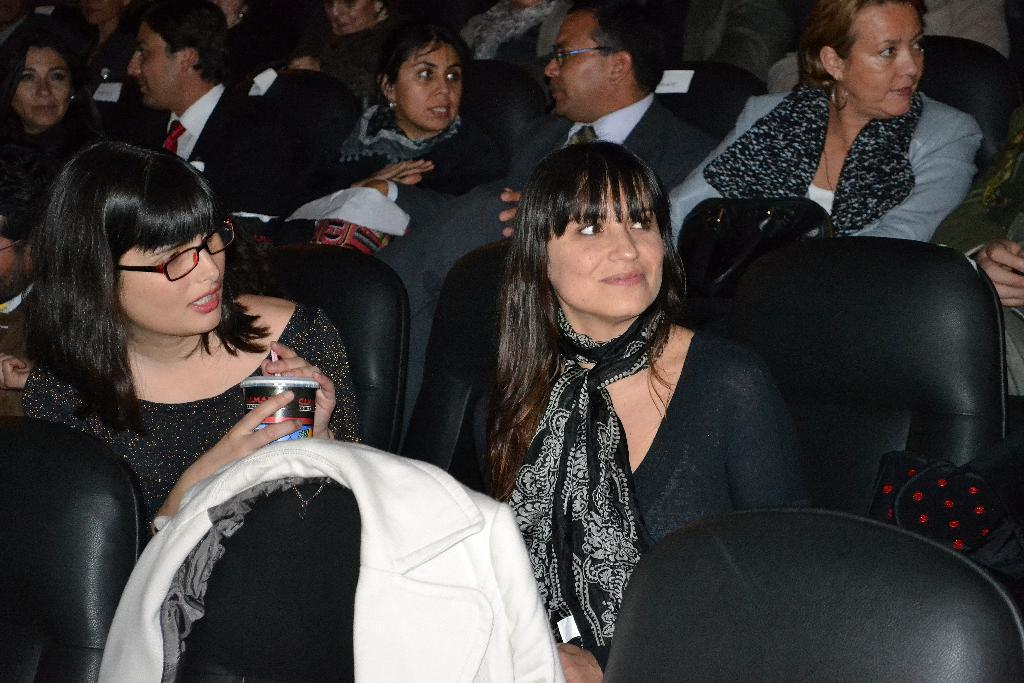Who or what can be seen in the image? There are people in the image. What are the people doing in the image? The people are sitting on chairs. What type of building is visible in the image? There is no building present in the image; it only shows people sitting on chairs. How many twigs can be seen in the image? There are no twigs present in the image. 